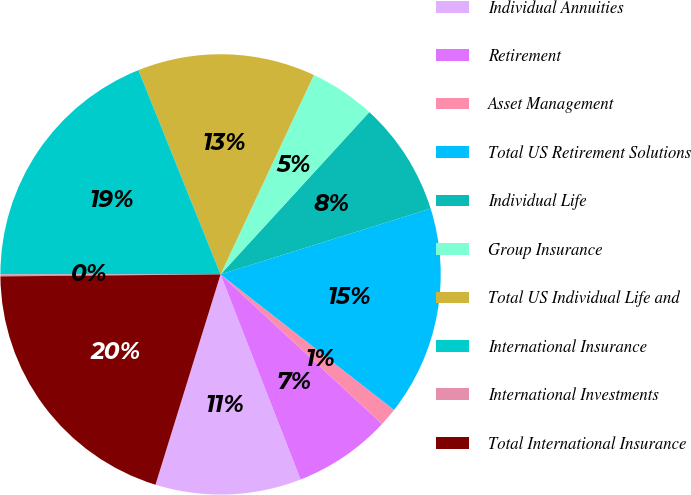Convert chart to OTSL. <chart><loc_0><loc_0><loc_500><loc_500><pie_chart><fcel>Individual Annuities<fcel>Retirement<fcel>Asset Management<fcel>Total US Retirement Solutions<fcel>Individual Life<fcel>Group Insurance<fcel>Total US Individual Life and<fcel>International Insurance<fcel>International Investments<fcel>Total International Insurance<nl><fcel>10.7%<fcel>7.19%<fcel>1.33%<fcel>15.39%<fcel>8.36%<fcel>4.84%<fcel>13.05%<fcel>18.91%<fcel>0.15%<fcel>20.08%<nl></chart> 